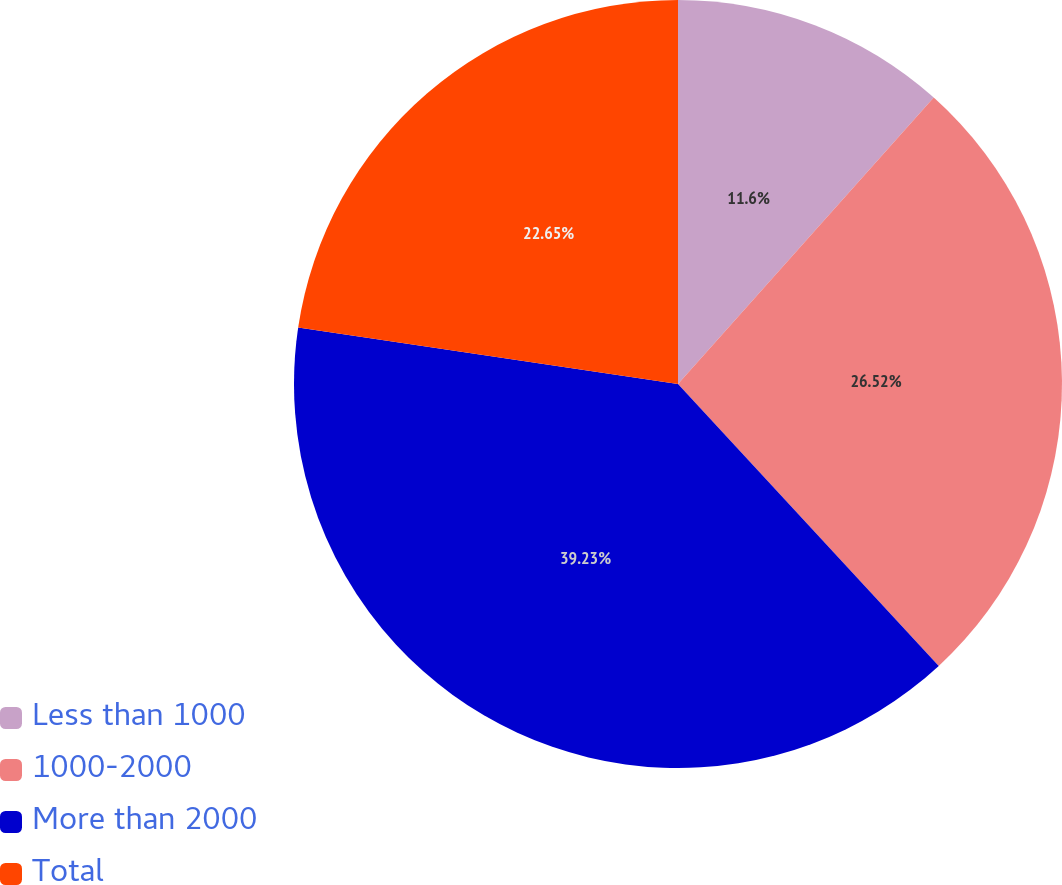Convert chart to OTSL. <chart><loc_0><loc_0><loc_500><loc_500><pie_chart><fcel>Less than 1000<fcel>1000-2000<fcel>More than 2000<fcel>Total<nl><fcel>11.6%<fcel>26.52%<fcel>39.23%<fcel>22.65%<nl></chart> 